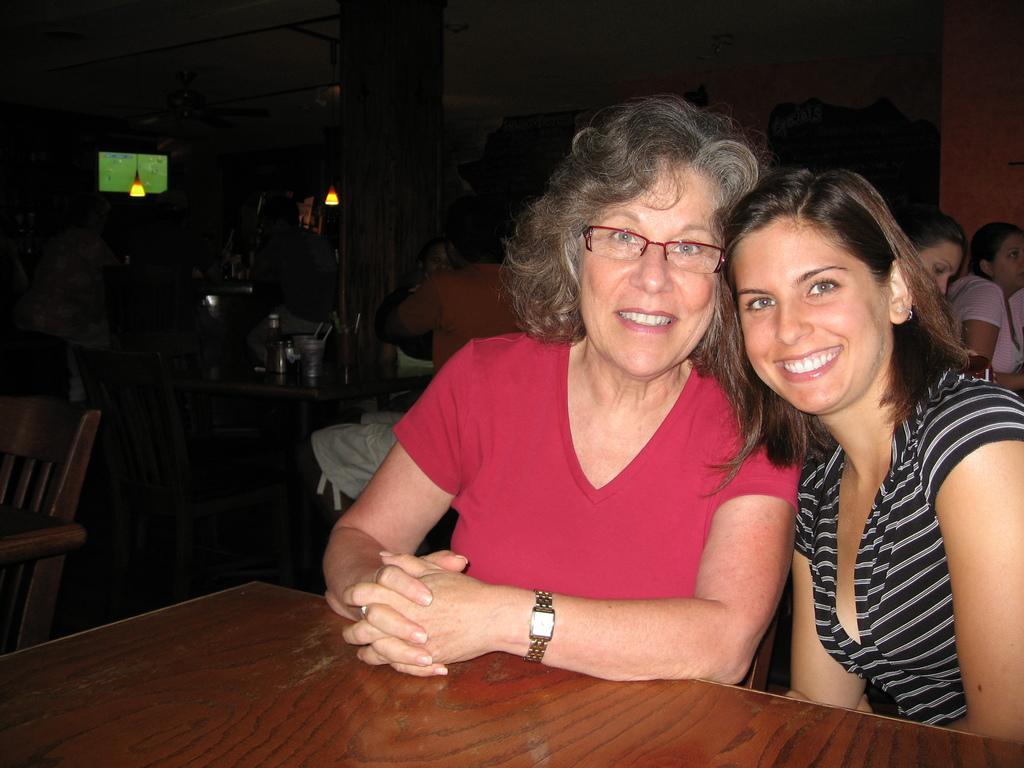Could you give a brief overview of what you see in this image? This is the picture of 2 women sitting in the chair and smiling and in the back ground we have lamp, chair, table and some group of persons sitting. 